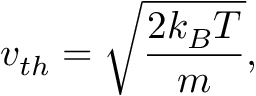<formula> <loc_0><loc_0><loc_500><loc_500>v _ { t h } = \sqrt { \frac { 2 k _ { B } T } { m } } ,</formula> 